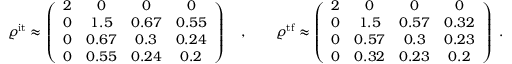Convert formula to latex. <formula><loc_0><loc_0><loc_500><loc_500>\begin{array} { r } { \varrho ^ { i t } \approx \left ( \begin{array} { c c c c } { 2 } & { 0 } & { 0 } & { 0 } \\ { 0 } & { 1 . 5 } & { 0 . 6 7 } & { 0 . 5 5 } \\ { 0 } & { 0 . 6 7 } & { 0 . 3 } & { 0 . 2 4 } \\ { 0 } & { 0 . 5 5 } & { 0 . 2 4 } & { 0 . 2 } \end{array} \right ) \quad , \quad \varrho ^ { t f } \approx \left ( \begin{array} { c c c c } { 2 } & { 0 } & { 0 } & { 0 } \\ { 0 } & { 1 . 5 } & { 0 . 5 7 } & { 0 . 3 2 } \\ { 0 } & { 0 . 5 7 } & { 0 . 3 } & { 0 . 2 3 } \\ { 0 } & { 0 . 3 2 } & { 0 . 2 3 } & { 0 . 2 } \end{array} \right ) \ . } \end{array}</formula> 